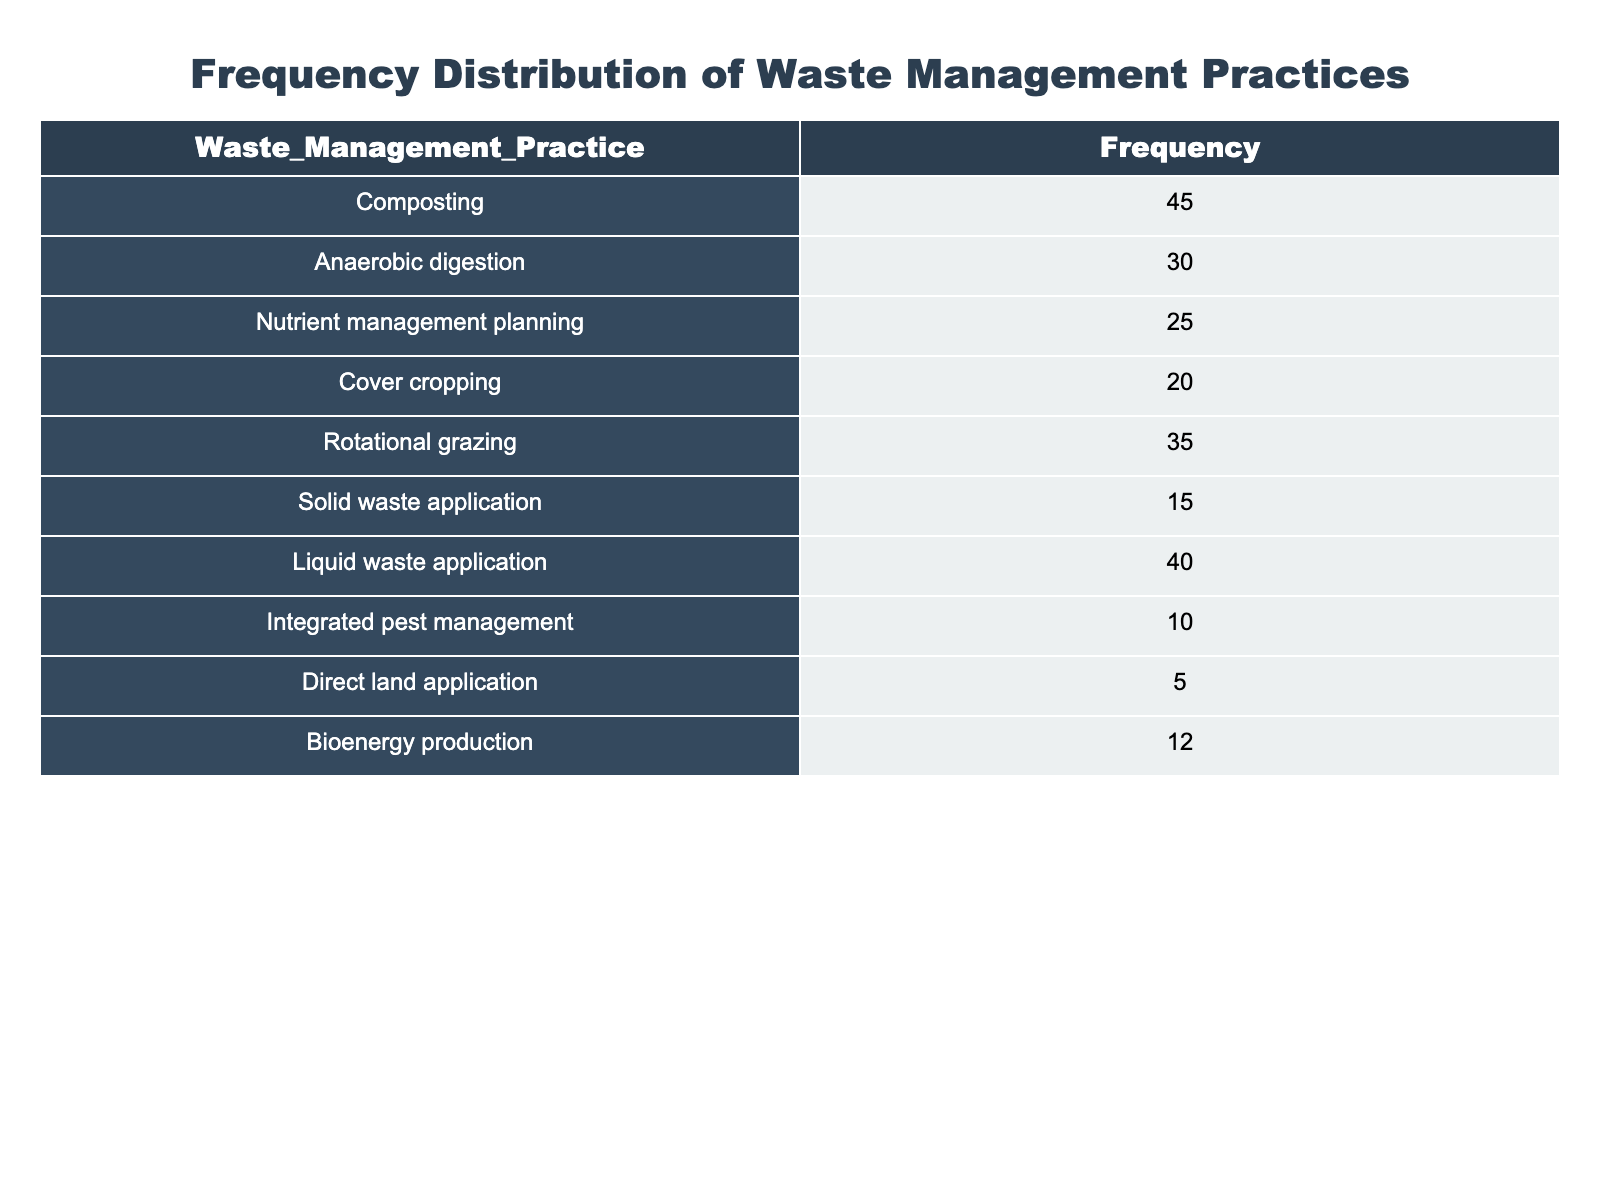What waste management practice has the highest frequency? The table shows that "Composting" has the highest frequency of 45 among all practices listed.
Answer: Composting What is the frequency of liquid waste application? The table indicates that the frequency of "Liquid waste application" is 40.
Answer: 40 Which waste management practice has the lowest frequency? Referring to the table, "Direct land application" has the lowest frequency, which is 5.
Answer: Direct land application What is the total frequency of all the waste management practices combined? To find the total frequency, sum all the frequencies: 45 + 30 + 25 + 20 + 35 + 15 + 40 + 10 + 5 + 12 = 232.
Answer: 232 Is the frequency of nutrient management planning greater than that of integrated pest management? The table shows that "Nutrient management planning" has a frequency of 25, while "Integrated pest management" has a frequency of 10. Thus, it is true that nutrient management planning has a greater frequency.
Answer: Yes Which three waste management practices have a frequency greater than 30? By examining the table, "Composting" (45), "Liquid waste application" (40), and "Rotational grazing" (35) all have frequencies greater than 30.
Answer: Composting, Liquid waste application, Rotational grazing What is the average frequency of the practices that involve crop management? The practices that involve crop management are "Cover cropping" (20) and "Nutrient management planning" (25). The sum is 20 + 25 = 45, and there are 2 practices, so the average frequency is 45 / 2 = 22.5.
Answer: 22.5 Is it true that more than half of the practices have a frequency of 20 or more? There are 10 practices listed. The ones with a frequency of 20 or more are "Composting," "Anaerobic digestion," "Rotational grazing," "Liquid waste application," and "Nutrient management planning." That’s 5 out of 10, which is half, so it is false that more than half have a frequency of 20 or more.
Answer: No What two practices combined have a frequency that is equal to or greater than 70? Looking at the frequencies, "Composting" (45) and "Liquid waste application" (40) sum to 85, which is greater than 70. Additionally, "Rotational grazing" (35) and "Anaerobic digestion" (30) sum to 65, which is less than 70. Hence, the combination of "Composting" and "Liquid waste application" meets the criteria.
Answer: Composting and Liquid waste application 